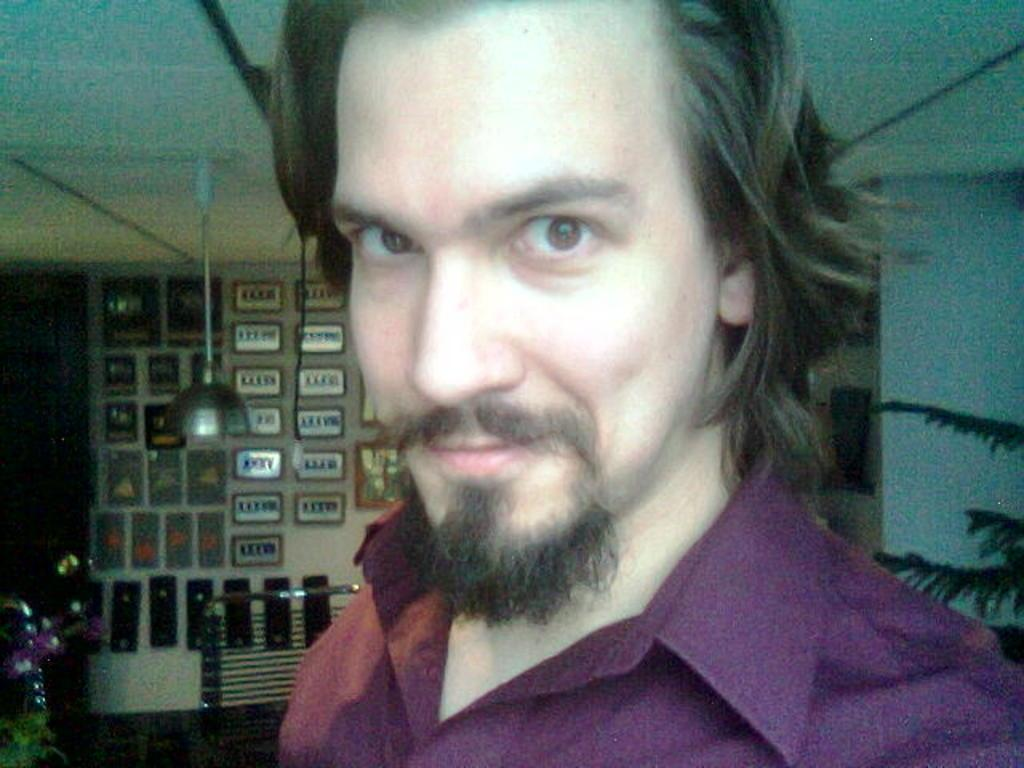Who is present in the image? There is a man in the image. What is the man doing in the image? The man is smiling in the image. What is the man wearing in the image? The man is wearing a shirt in the image. What can be seen on the right side of the image? There are leaves of a plant on the right side of the image. What is on the wall on the left side of the image? There are boards on the wall on the left side of the image. What type of cloud can be seen playing with the man in the image? There is no cloud present in the image, and the man is not interacting with any playful objects or entities. 